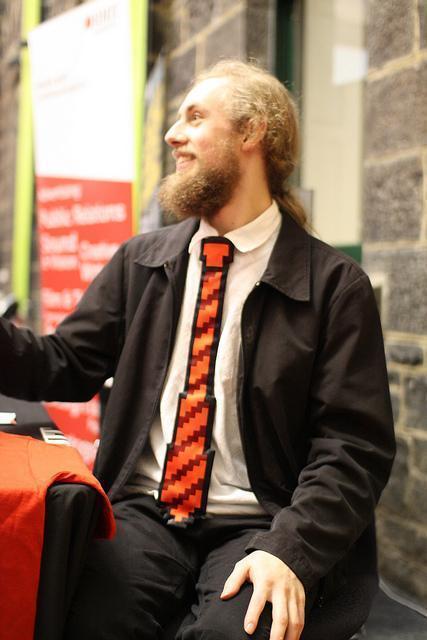What unusual design does his tie have?
Choose the right answer from the provided options to respond to the question.
Options: Optical illusion, polka dots, like pixels, cartoons. Like pixels. 